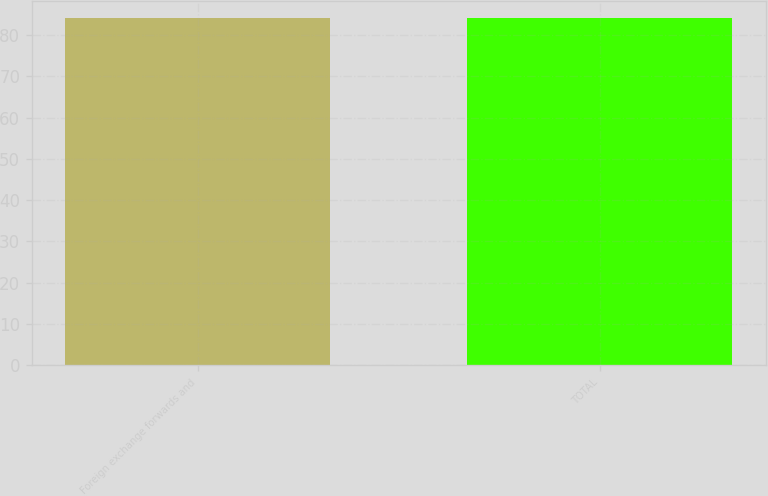<chart> <loc_0><loc_0><loc_500><loc_500><bar_chart><fcel>Foreign exchange forwards and<fcel>TOTAL<nl><fcel>84<fcel>84.1<nl></chart> 